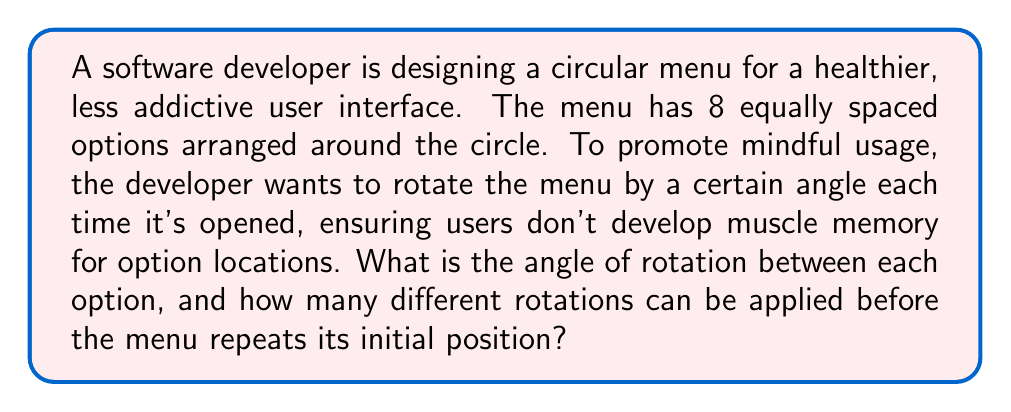Give your solution to this math problem. Let's approach this step-by-step:

1) First, we need to calculate the angle between each option in the circular menu:
   - A circle has 360°
   - There are 8 options
   - Angle between options = $\frac{360°}{8} = 45°$

2) Now, we need to determine how many unique rotations can be applied:
   - Each rotation must be a multiple of 45° to align with the option positions
   - The menu will repeat its initial position after a full 360° rotation
   - Number of unique rotations = $\frac{360°}{45°} = 8$

3) We can verify this:
   - 1st rotation: 45°
   - 2nd rotation: 90°
   - 3rd rotation: 135°
   - 4th rotation: 180°
   - 5th rotation: 225°
   - 6th rotation: 270°
   - 7th rotation: 315°
   - 8th rotation: 360° (back to initial position)

4) Therefore, there are 7 unique rotations (excluding the initial position) that can be applied to the menu before it repeats.

[asy]
unitsize(1cm);
draw(circle((0,0),3));
for(int i=0; i<8; ++i) {
  draw((0,0)--3*dir(i*45));
  dot(3*dir(i*45));
}
label("45°", 1.5*dir(22.5), NE);
[/asy]
Answer: 45°; 7 rotations 